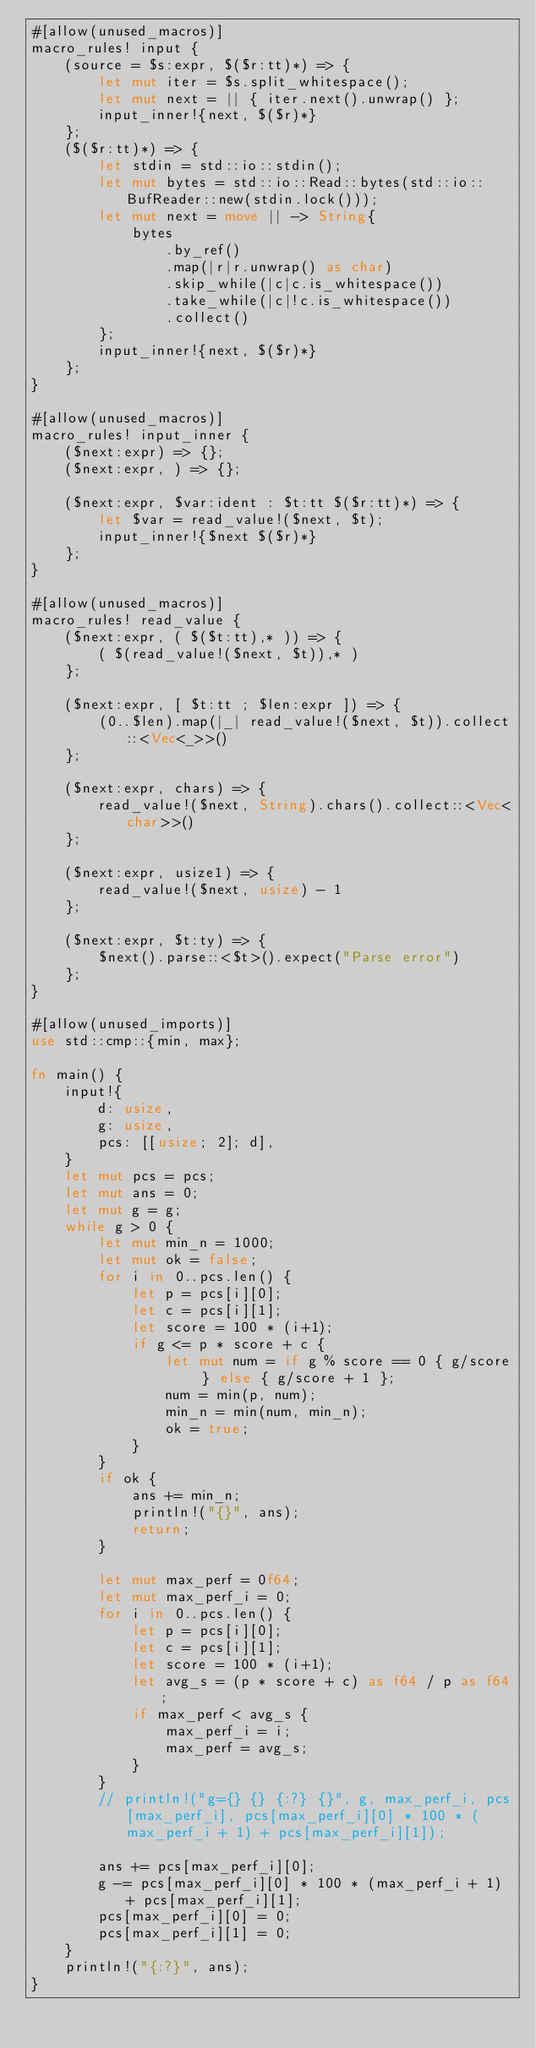Convert code to text. <code><loc_0><loc_0><loc_500><loc_500><_Rust_>#[allow(unused_macros)]
macro_rules! input {
    (source = $s:expr, $($r:tt)*) => {
        let mut iter = $s.split_whitespace();
        let mut next = || { iter.next().unwrap() };
        input_inner!{next, $($r)*}
    };
    ($($r:tt)*) => {
        let stdin = std::io::stdin();
        let mut bytes = std::io::Read::bytes(std::io::BufReader::new(stdin.lock()));
        let mut next = move || -> String{
            bytes
                .by_ref()
                .map(|r|r.unwrap() as char)
                .skip_while(|c|c.is_whitespace())
                .take_while(|c|!c.is_whitespace())
                .collect()
        };
        input_inner!{next, $($r)*}
    };
}

#[allow(unused_macros)]
macro_rules! input_inner {
    ($next:expr) => {};
    ($next:expr, ) => {};

    ($next:expr, $var:ident : $t:tt $($r:tt)*) => {
        let $var = read_value!($next, $t);
        input_inner!{$next $($r)*}
    };
}

#[allow(unused_macros)]
macro_rules! read_value {
    ($next:expr, ( $($t:tt),* )) => {
        ( $(read_value!($next, $t)),* )
    };

    ($next:expr, [ $t:tt ; $len:expr ]) => {
        (0..$len).map(|_| read_value!($next, $t)).collect::<Vec<_>>()
    };

    ($next:expr, chars) => {
        read_value!($next, String).chars().collect::<Vec<char>>()
    };

    ($next:expr, usize1) => {
        read_value!($next, usize) - 1
    };

    ($next:expr, $t:ty) => {
        $next().parse::<$t>().expect("Parse error")
    };
}

#[allow(unused_imports)]
use std::cmp::{min, max};

fn main() {
    input!{
        d: usize,
        g: usize,
        pcs: [[usize; 2]; d],
    }
    let mut pcs = pcs;
    let mut ans = 0;
    let mut g = g;
    while g > 0 {
        let mut min_n = 1000;
        let mut ok = false;
        for i in 0..pcs.len() {
            let p = pcs[i][0];
            let c = pcs[i][1];
            let score = 100 * (i+1);
            if g <= p * score + c {
                let mut num = if g % score == 0 { g/score } else { g/score + 1 };
                num = min(p, num);
                min_n = min(num, min_n);
                ok = true;
            }
        }
        if ok {
            ans += min_n;
            println!("{}", ans);
            return;
        }

        let mut max_perf = 0f64;
        let mut max_perf_i = 0;
        for i in 0..pcs.len() {
            let p = pcs[i][0];
            let c = pcs[i][1];
            let score = 100 * (i+1);
            let avg_s = (p * score + c) as f64 / p as f64;
            if max_perf < avg_s {
                max_perf_i = i;
                max_perf = avg_s;
            }
        }
        // println!("g={} {} {:?} {}", g, max_perf_i, pcs[max_perf_i], pcs[max_perf_i][0] * 100 * (max_perf_i + 1) + pcs[max_perf_i][1]);

        ans += pcs[max_perf_i][0];
        g -= pcs[max_perf_i][0] * 100 * (max_perf_i + 1) + pcs[max_perf_i][1];
        pcs[max_perf_i][0] = 0;
        pcs[max_perf_i][1] = 0;
    }
    println!("{:?}", ans);
}
</code> 